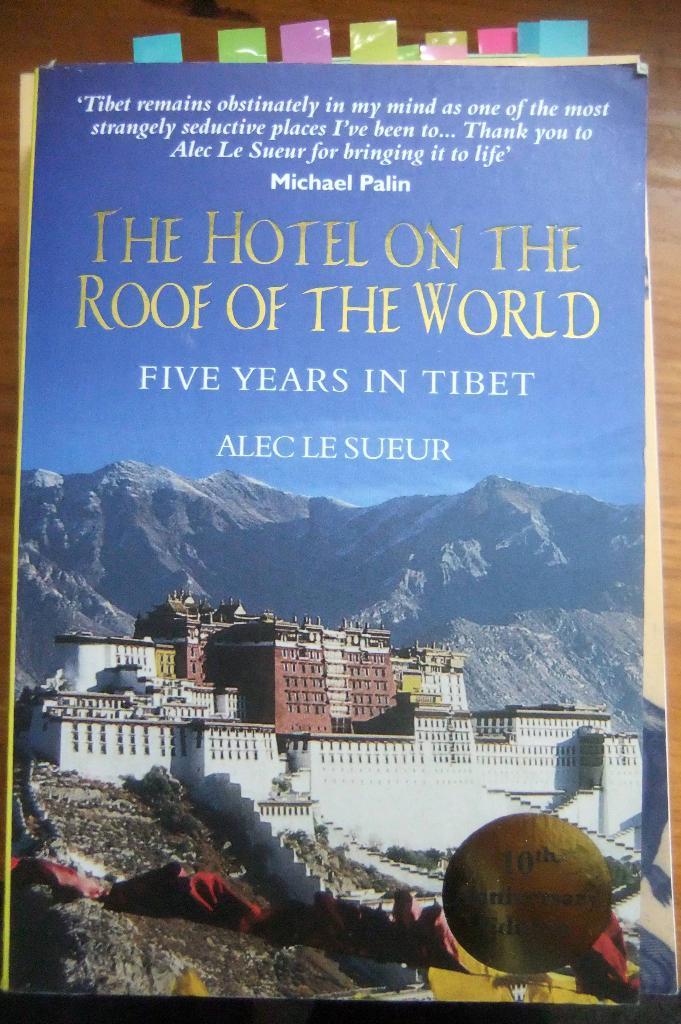What is the title of the book?
Make the answer very short. The hotel on the roof of the world. Who wrote the book?
Keep it short and to the point. Alec le sueur. 